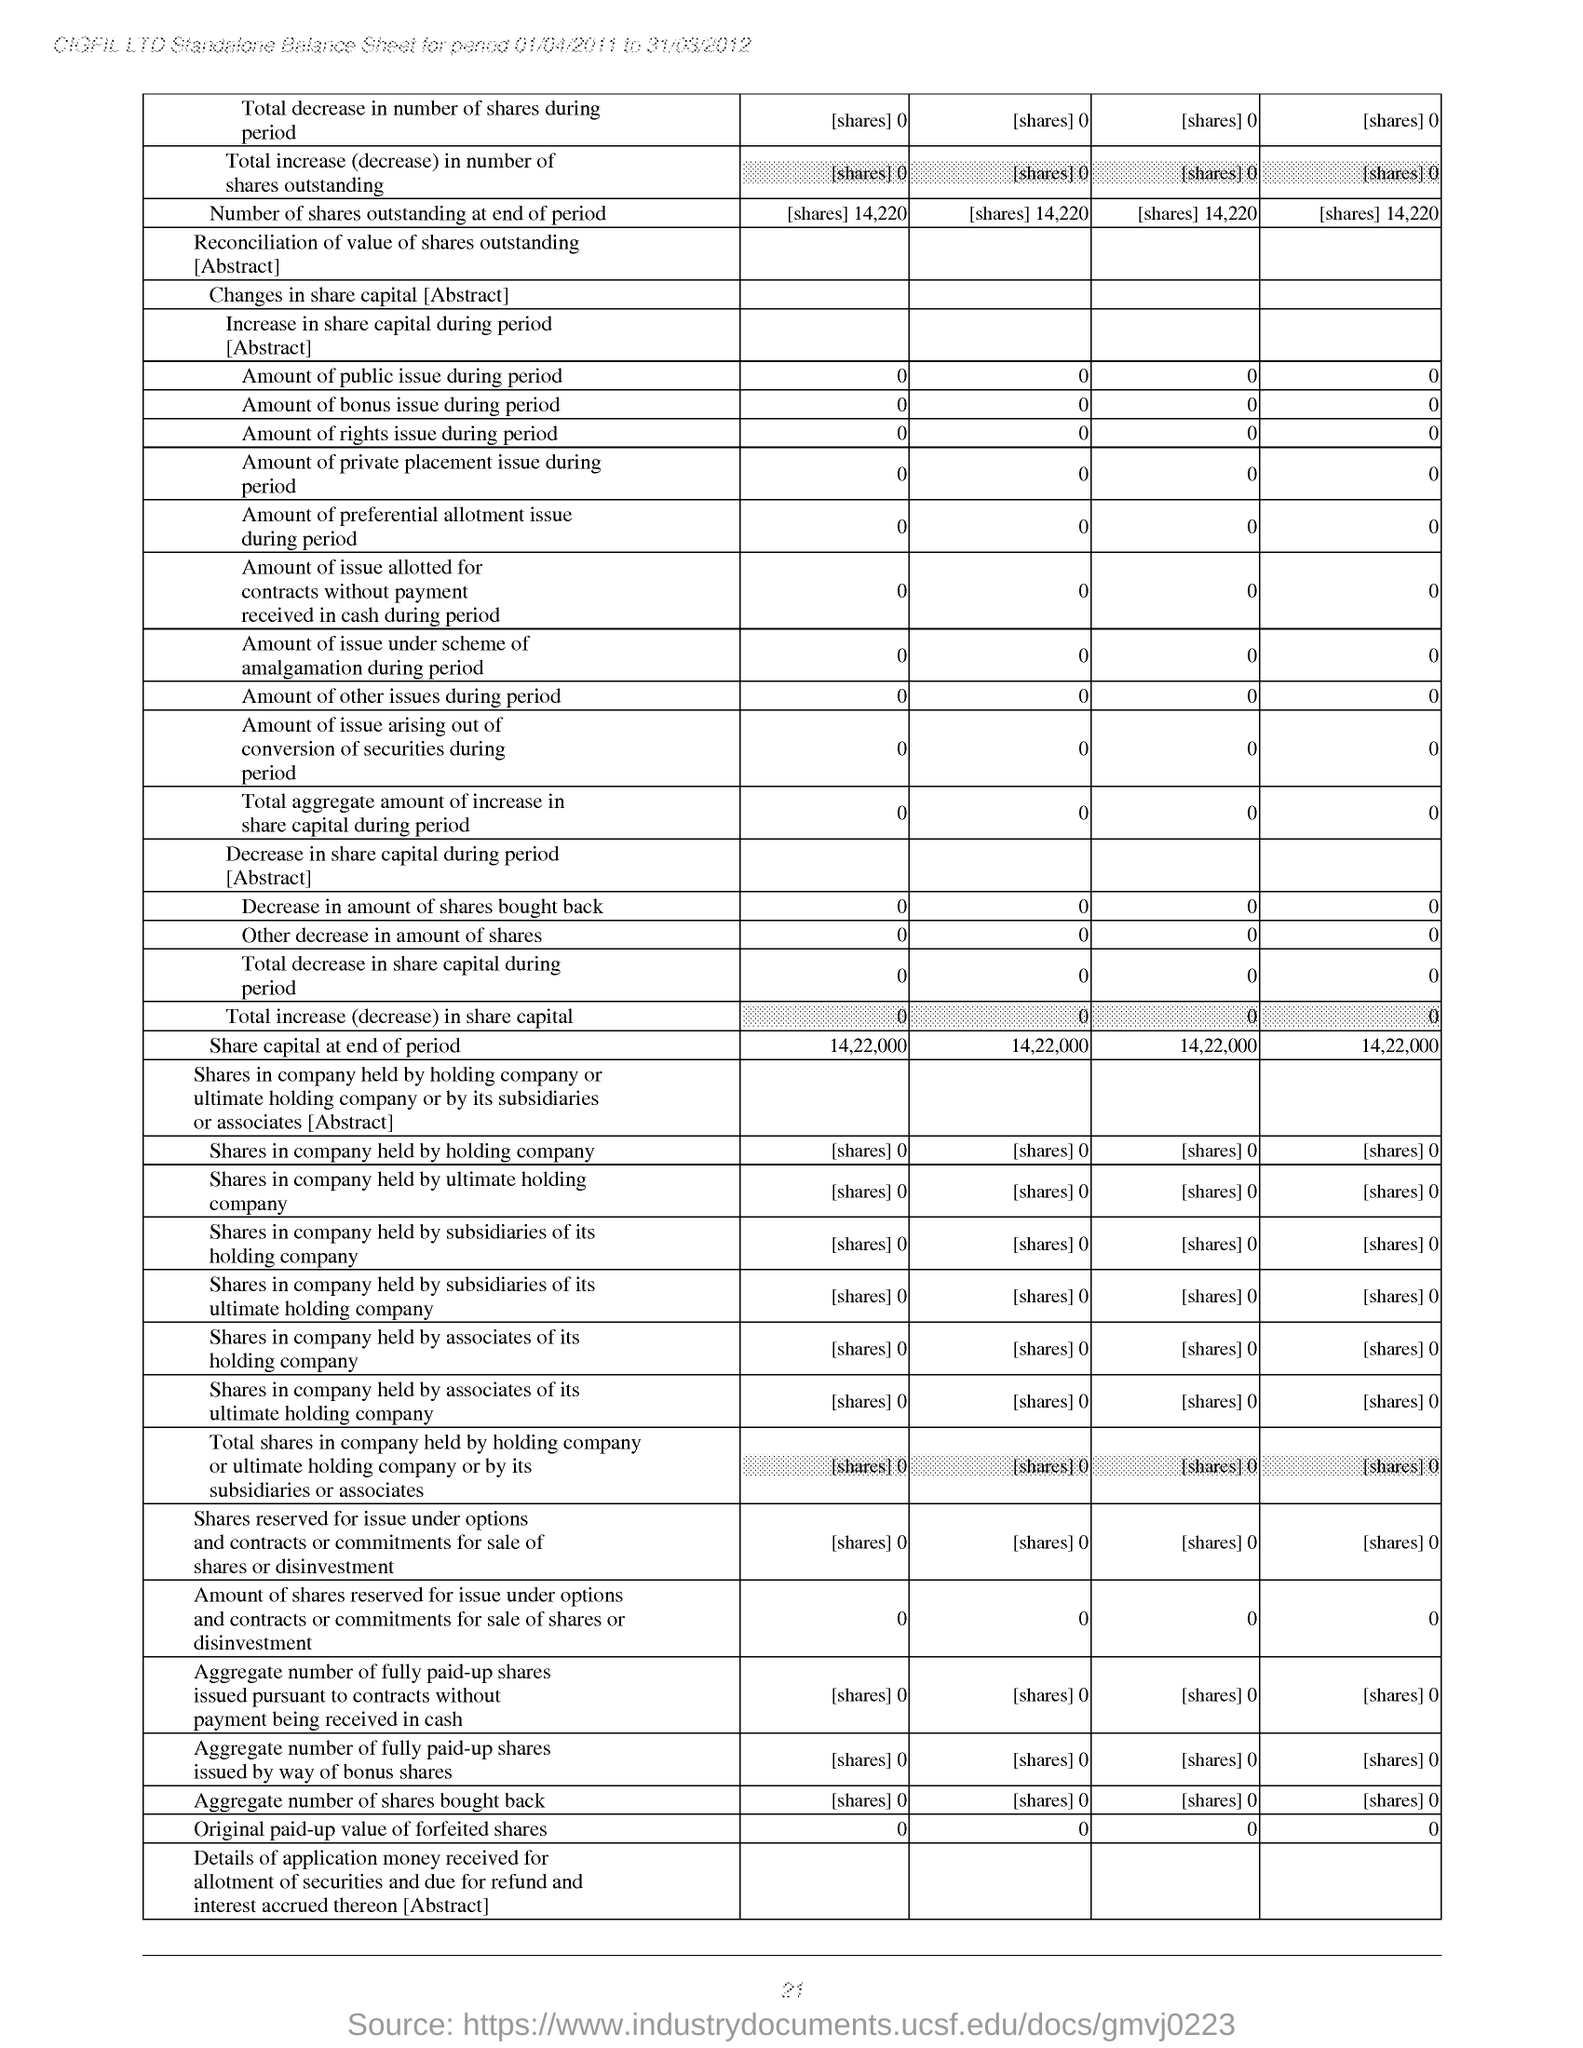What is the share capital at end of period?
Offer a terse response. 14,22,000. 